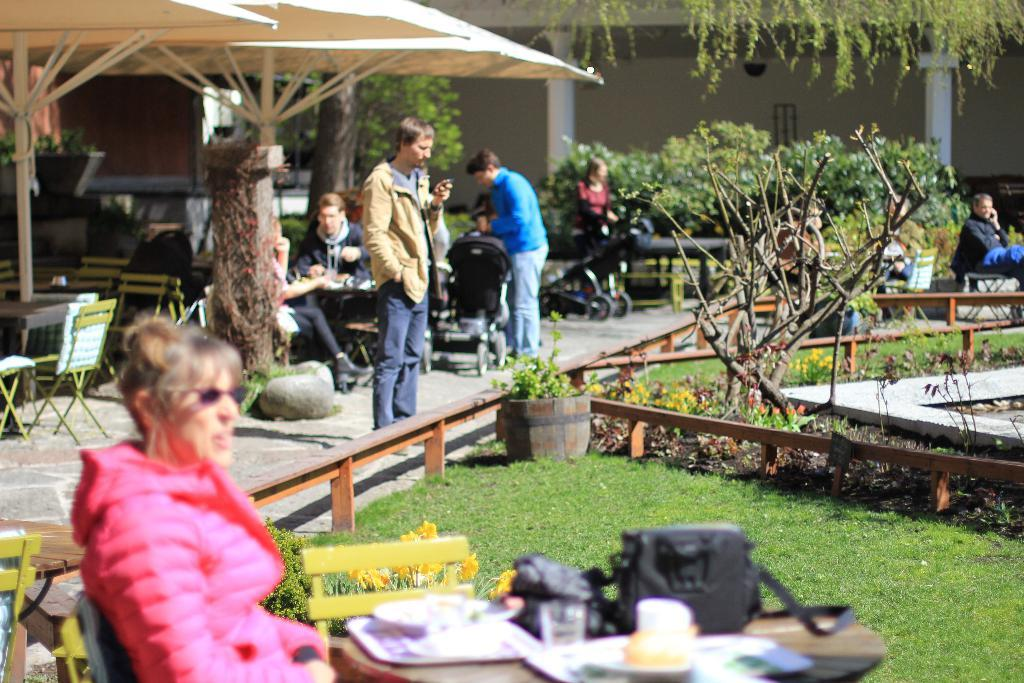What type of vegetation is present in the image? There are trees, grass, and plants in the image. What type of furniture is visible in the image? There are tables and chairs in the image. What are the people in the image doing? Some people are standing, while others are sitting in the image. Can you see a person carrying a tray in the image? There is no person carrying a tray in the image. Is this image taken at an airport? The provided facts do not mention an airport, so we cannot determine if the image was taken at an airport. 